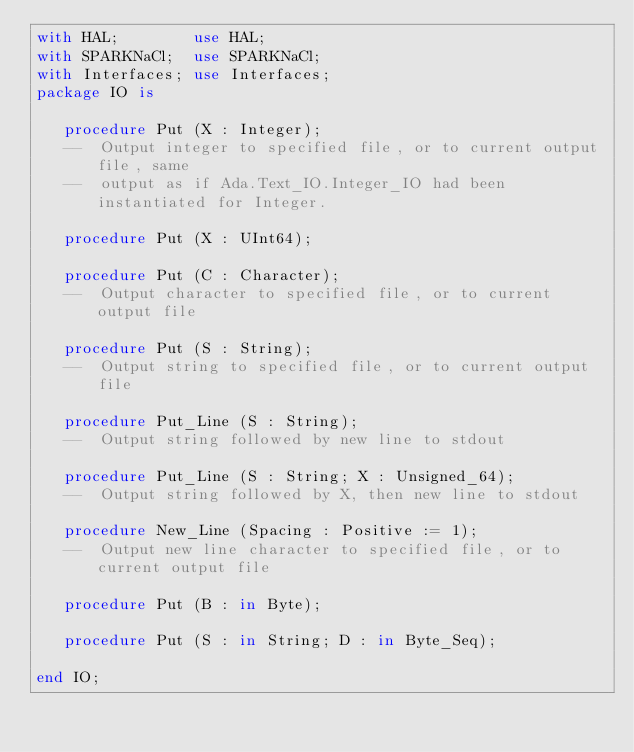Convert code to text. <code><loc_0><loc_0><loc_500><loc_500><_Ada_>with HAL;        use HAL;
with SPARKNaCl;  use SPARKNaCl;
with Interfaces; use Interfaces;
package IO is

   procedure Put (X : Integer);
   --  Output integer to specified file, or to current output file, same
   --  output as if Ada.Text_IO.Integer_IO had been instantiated for Integer.

   procedure Put (X : UInt64);

   procedure Put (C : Character);
   --  Output character to specified file, or to current output file

   procedure Put (S : String);
   --  Output string to specified file, or to current output file

   procedure Put_Line (S : String);
   --  Output string followed by new line to stdout

   procedure Put_Line (S : String; X : Unsigned_64);
   --  Output string followed by X, then new line to stdout

   procedure New_Line (Spacing : Positive := 1);
   --  Output new line character to specified file, or to current output file

   procedure Put (B : in Byte);

   procedure Put (S : in String; D : in Byte_Seq);

end IO;
</code> 